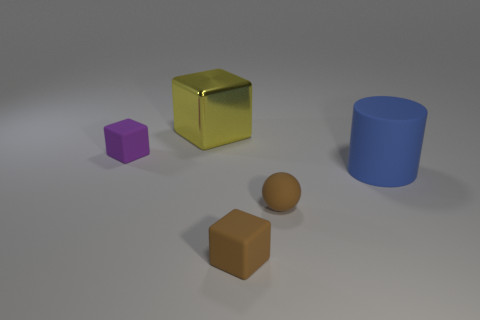Subtract all balls. How many objects are left? 4 Add 1 spheres. How many objects exist? 6 Subtract all purple blocks. How many blocks are left? 2 Subtract all tiny blocks. How many blocks are left? 1 Subtract 0 green balls. How many objects are left? 5 Subtract 1 cylinders. How many cylinders are left? 0 Subtract all yellow cubes. Subtract all red spheres. How many cubes are left? 2 Subtract all blue cylinders. How many yellow blocks are left? 1 Subtract all yellow metallic things. Subtract all big cubes. How many objects are left? 3 Add 4 yellow objects. How many yellow objects are left? 5 